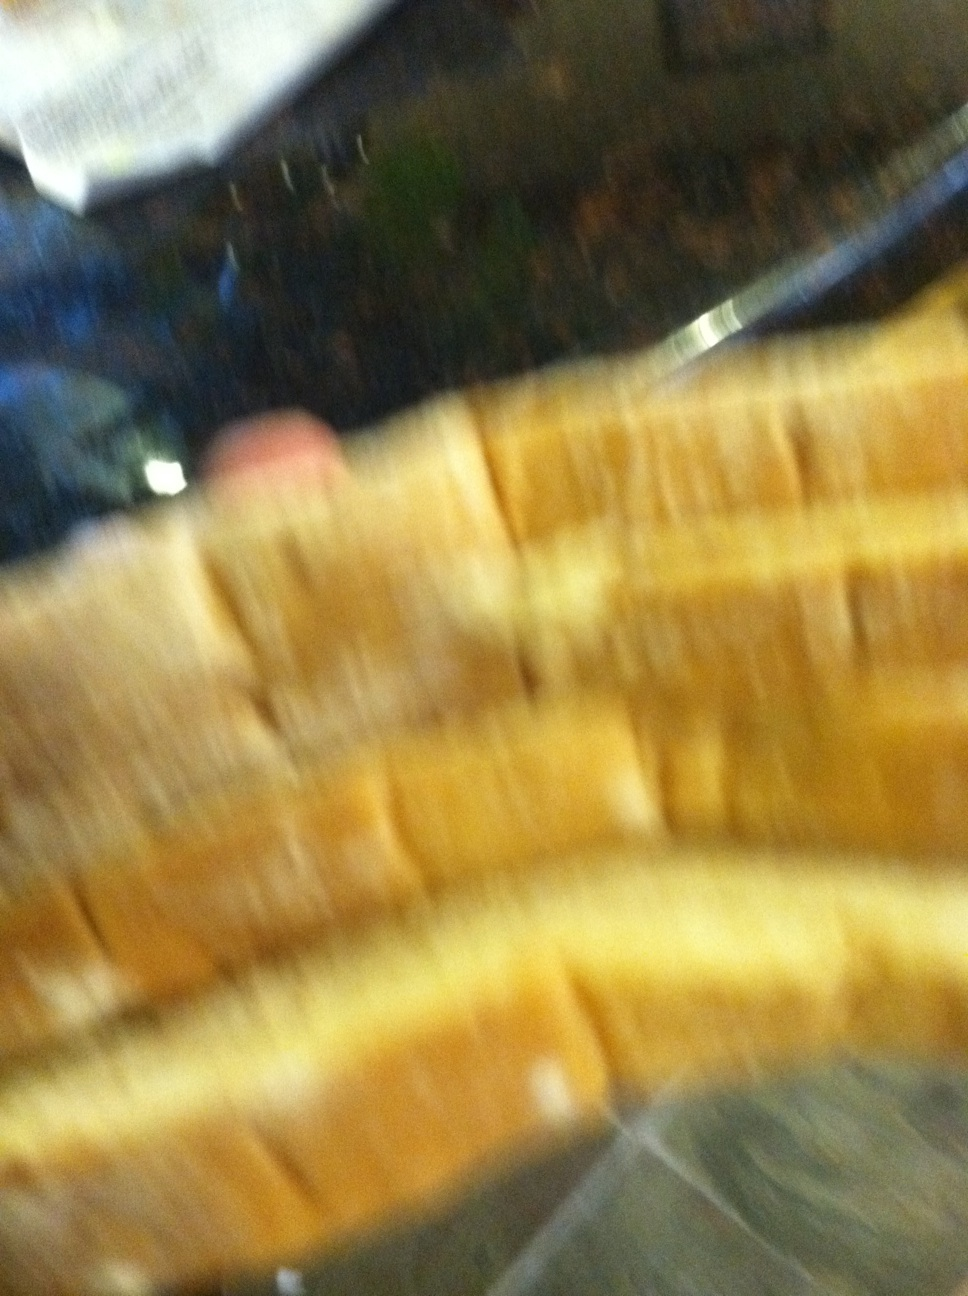What kind of bread is this? The image shows several slices of bread that are likely from a sandwich loaf, possibly white bread. However, the image is quite blurry, making it hard to determine with certainty. Do you think the bread is fresh? Based on the image, it's difficult to tell if the bread is fresh. Usually, fresh bread has a soft texture and a pleasant aroma, but these details can't be discerned from the picture alone. Imagine this bread is part of a magical feast. What other wonderful foods might accompany it? At this magical feast, the bread could be surrounded by a variety of enchanting dishes. Imagine golden soups that bubble with mystical energy, platters of fruit that glisten like gems, cheeses that emit a soft, otherworldly glow, and meats perfectly roasted to a tender, savory perfection. And perhaps, beside each dish, there are pots of magical sauces that add a touch of whimsy to every bite! 